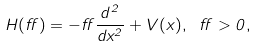<formula> <loc_0><loc_0><loc_500><loc_500>H ( \alpha ) = - \alpha \frac { d ^ { 2 } } { d x ^ { 2 } } + V ( x ) , \ \alpha > 0 ,</formula> 